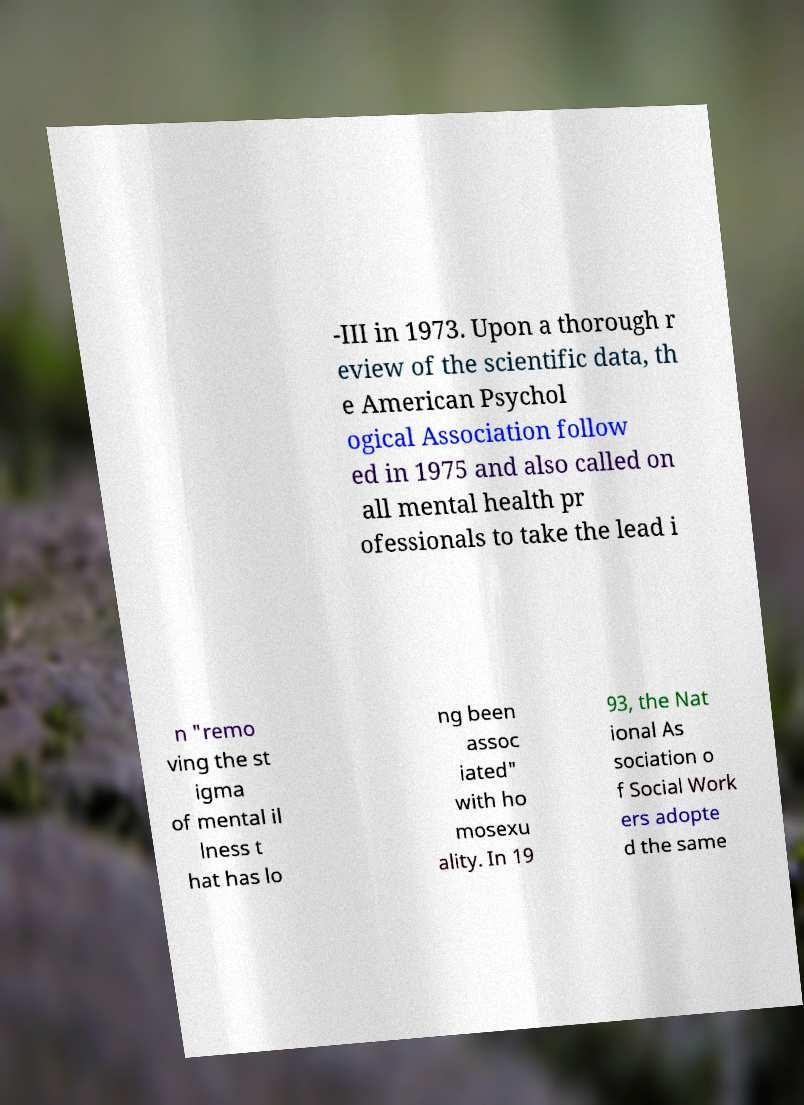Can you read and provide the text displayed in the image?This photo seems to have some interesting text. Can you extract and type it out for me? -III in 1973. Upon a thorough r eview of the scientific data, th e American Psychol ogical Association follow ed in 1975 and also called on all mental health pr ofessionals to take the lead i n "remo ving the st igma of mental il lness t hat has lo ng been assoc iated" with ho mosexu ality. In 19 93, the Nat ional As sociation o f Social Work ers adopte d the same 